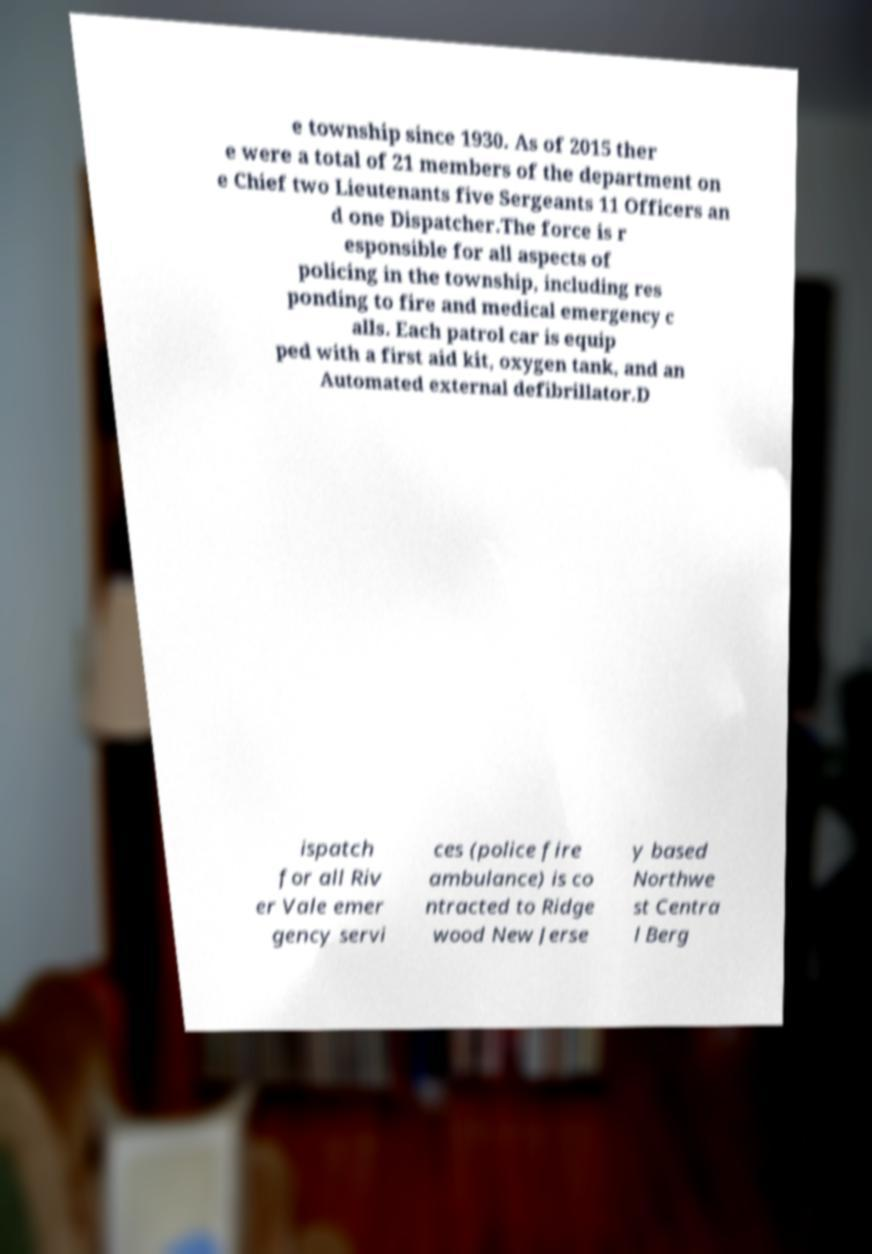Please read and relay the text visible in this image. What does it say? e township since 1930. As of 2015 ther e were a total of 21 members of the department on e Chief two Lieutenants five Sergeants 11 Officers an d one Dispatcher.The force is r esponsible for all aspects of policing in the township, including res ponding to fire and medical emergency c alls. Each patrol car is equip ped with a first aid kit, oxygen tank, and an Automated external defibrillator.D ispatch for all Riv er Vale emer gency servi ces (police fire ambulance) is co ntracted to Ridge wood New Jerse y based Northwe st Centra l Berg 